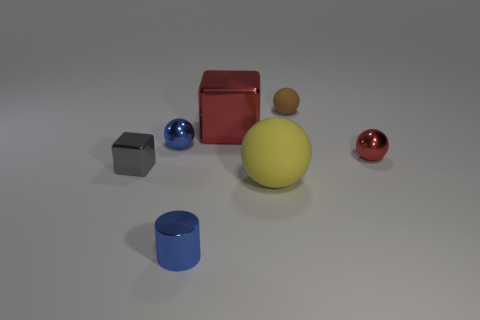Does the small brown thing have the same shape as the tiny gray thing?
Your answer should be very brief. No. What number of things are red spheres behind the yellow rubber thing or tiny shiny balls that are on the right side of the large yellow matte ball?
Keep it short and to the point. 1. How many matte balls are behind the small shiny sphere that is on the right side of the small blue thing in front of the tiny shiny block?
Your answer should be compact. 1. How big is the red object that is to the right of the tiny brown object?
Provide a succinct answer. Small. How many blue shiny balls have the same size as the brown object?
Provide a succinct answer. 1. There is a brown thing; is its size the same as the red metal object that is to the left of the tiny red sphere?
Offer a very short reply. No. What number of things are red metal things or big objects?
Your response must be concise. 3. How many metal things have the same color as the large metallic block?
Offer a very short reply. 1. The gray object that is the same size as the blue metal sphere is what shape?
Make the answer very short. Cube. Is there a small object of the same shape as the big red metal object?
Your answer should be compact. Yes. 